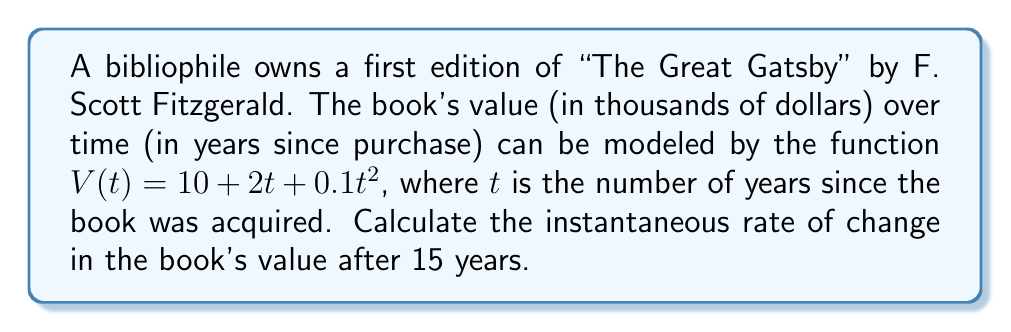What is the answer to this math problem? To find the instantaneous rate of change in the book's value after 15 years, we need to calculate the derivative of the given function $V(t)$ and evaluate it at $t = 15$.

1. Given function: $V(t) = 10 + 2t + 0.1t^2$

2. To find the rate of change, we need to differentiate $V(t)$ with respect to $t$:
   $$\frac{dV}{dt} = \frac{d}{dt}(10 + 2t + 0.1t^2)$$

3. Using the power rule and constant rule of differentiation:
   $$\frac{dV}{dt} = 0 + 2 + 0.1 \cdot 2t$$
   $$\frac{dV}{dt} = 2 + 0.2t$$

4. This derivative represents the instantaneous rate of change of the book's value at any time $t$.

5. To find the rate of change after 15 years, we substitute $t = 15$ into the derivative:
   $$\frac{dV}{dt}\bigg|_{t=15} = 2 + 0.2(15)$$
   $$\frac{dV}{dt}\bigg|_{t=15} = 2 + 3 = 5$$

6. The units of this rate are thousands of dollars per year.
Answer: The instantaneous rate of change in the book's value after 15 years is $5$ thousand dollars per year. 